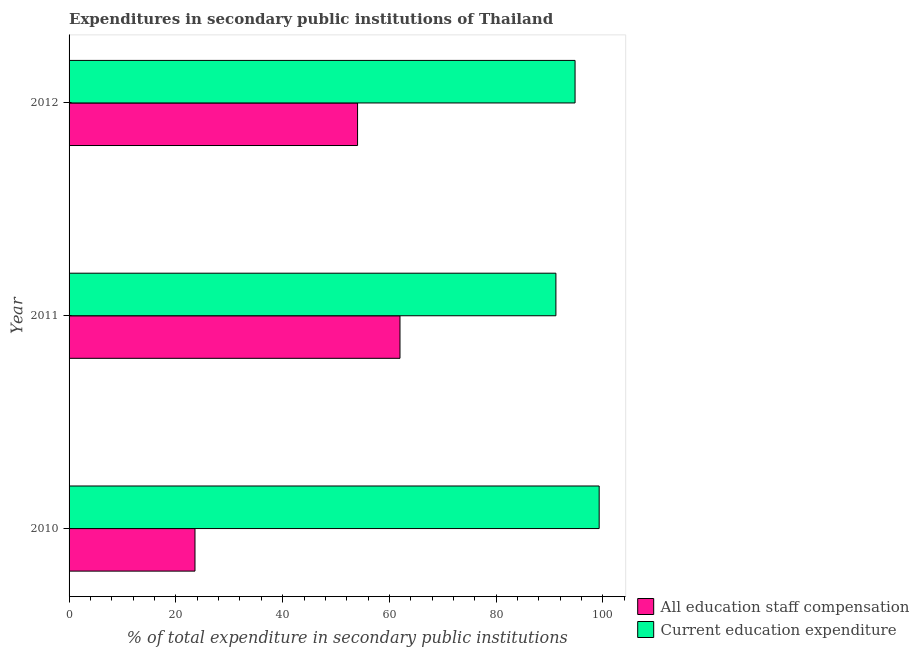How many different coloured bars are there?
Provide a short and direct response. 2. How many groups of bars are there?
Provide a short and direct response. 3. How many bars are there on the 2nd tick from the top?
Your answer should be very brief. 2. How many bars are there on the 1st tick from the bottom?
Offer a very short reply. 2. What is the label of the 2nd group of bars from the top?
Your answer should be very brief. 2011. What is the expenditure in education in 2012?
Your answer should be very brief. 94.77. Across all years, what is the maximum expenditure in education?
Make the answer very short. 99.29. Across all years, what is the minimum expenditure in education?
Your answer should be very brief. 91.18. In which year was the expenditure in staff compensation minimum?
Your answer should be compact. 2010. What is the total expenditure in staff compensation in the graph?
Your answer should be compact. 139.59. What is the difference between the expenditure in education in 2010 and that in 2011?
Give a very brief answer. 8.1. What is the difference between the expenditure in staff compensation in 2011 and the expenditure in education in 2010?
Offer a terse response. -37.31. What is the average expenditure in education per year?
Offer a terse response. 95.08. In the year 2010, what is the difference between the expenditure in education and expenditure in staff compensation?
Your answer should be very brief. 75.7. What is the ratio of the expenditure in staff compensation in 2010 to that in 2011?
Your response must be concise. 0.38. Is the expenditure in education in 2011 less than that in 2012?
Provide a succinct answer. Yes. Is the difference between the expenditure in staff compensation in 2010 and 2012 greater than the difference between the expenditure in education in 2010 and 2012?
Keep it short and to the point. No. What is the difference between the highest and the second highest expenditure in education?
Make the answer very short. 4.52. In how many years, is the expenditure in education greater than the average expenditure in education taken over all years?
Give a very brief answer. 1. What does the 1st bar from the top in 2012 represents?
Provide a succinct answer. Current education expenditure. What does the 2nd bar from the bottom in 2010 represents?
Keep it short and to the point. Current education expenditure. How many bars are there?
Your answer should be very brief. 6. Are the values on the major ticks of X-axis written in scientific E-notation?
Provide a succinct answer. No. Does the graph contain grids?
Your response must be concise. No. How are the legend labels stacked?
Your answer should be very brief. Vertical. What is the title of the graph?
Make the answer very short. Expenditures in secondary public institutions of Thailand. What is the label or title of the X-axis?
Make the answer very short. % of total expenditure in secondary public institutions. What is the % of total expenditure in secondary public institutions in All education staff compensation in 2010?
Ensure brevity in your answer.  23.58. What is the % of total expenditure in secondary public institutions of Current education expenditure in 2010?
Make the answer very short. 99.29. What is the % of total expenditure in secondary public institutions of All education staff compensation in 2011?
Offer a very short reply. 61.98. What is the % of total expenditure in secondary public institutions of Current education expenditure in 2011?
Provide a short and direct response. 91.18. What is the % of total expenditure in secondary public institutions in All education staff compensation in 2012?
Your response must be concise. 54.03. What is the % of total expenditure in secondary public institutions in Current education expenditure in 2012?
Give a very brief answer. 94.77. Across all years, what is the maximum % of total expenditure in secondary public institutions of All education staff compensation?
Give a very brief answer. 61.98. Across all years, what is the maximum % of total expenditure in secondary public institutions of Current education expenditure?
Ensure brevity in your answer.  99.29. Across all years, what is the minimum % of total expenditure in secondary public institutions in All education staff compensation?
Give a very brief answer. 23.58. Across all years, what is the minimum % of total expenditure in secondary public institutions in Current education expenditure?
Ensure brevity in your answer.  91.18. What is the total % of total expenditure in secondary public institutions in All education staff compensation in the graph?
Make the answer very short. 139.59. What is the total % of total expenditure in secondary public institutions in Current education expenditure in the graph?
Offer a terse response. 285.24. What is the difference between the % of total expenditure in secondary public institutions in All education staff compensation in 2010 and that in 2011?
Your answer should be very brief. -38.4. What is the difference between the % of total expenditure in secondary public institutions in Current education expenditure in 2010 and that in 2011?
Provide a succinct answer. 8.1. What is the difference between the % of total expenditure in secondary public institutions of All education staff compensation in 2010 and that in 2012?
Ensure brevity in your answer.  -30.45. What is the difference between the % of total expenditure in secondary public institutions in Current education expenditure in 2010 and that in 2012?
Offer a terse response. 4.52. What is the difference between the % of total expenditure in secondary public institutions in All education staff compensation in 2011 and that in 2012?
Provide a short and direct response. 7.95. What is the difference between the % of total expenditure in secondary public institutions of Current education expenditure in 2011 and that in 2012?
Offer a very short reply. -3.59. What is the difference between the % of total expenditure in secondary public institutions in All education staff compensation in 2010 and the % of total expenditure in secondary public institutions in Current education expenditure in 2011?
Your response must be concise. -67.6. What is the difference between the % of total expenditure in secondary public institutions in All education staff compensation in 2010 and the % of total expenditure in secondary public institutions in Current education expenditure in 2012?
Make the answer very short. -71.19. What is the difference between the % of total expenditure in secondary public institutions in All education staff compensation in 2011 and the % of total expenditure in secondary public institutions in Current education expenditure in 2012?
Ensure brevity in your answer.  -32.79. What is the average % of total expenditure in secondary public institutions of All education staff compensation per year?
Keep it short and to the point. 46.53. What is the average % of total expenditure in secondary public institutions in Current education expenditure per year?
Make the answer very short. 95.08. In the year 2010, what is the difference between the % of total expenditure in secondary public institutions in All education staff compensation and % of total expenditure in secondary public institutions in Current education expenditure?
Provide a short and direct response. -75.7. In the year 2011, what is the difference between the % of total expenditure in secondary public institutions in All education staff compensation and % of total expenditure in secondary public institutions in Current education expenditure?
Offer a terse response. -29.2. In the year 2012, what is the difference between the % of total expenditure in secondary public institutions in All education staff compensation and % of total expenditure in secondary public institutions in Current education expenditure?
Your response must be concise. -40.74. What is the ratio of the % of total expenditure in secondary public institutions in All education staff compensation in 2010 to that in 2011?
Offer a very short reply. 0.38. What is the ratio of the % of total expenditure in secondary public institutions in Current education expenditure in 2010 to that in 2011?
Ensure brevity in your answer.  1.09. What is the ratio of the % of total expenditure in secondary public institutions in All education staff compensation in 2010 to that in 2012?
Offer a very short reply. 0.44. What is the ratio of the % of total expenditure in secondary public institutions in Current education expenditure in 2010 to that in 2012?
Your response must be concise. 1.05. What is the ratio of the % of total expenditure in secondary public institutions of All education staff compensation in 2011 to that in 2012?
Offer a very short reply. 1.15. What is the ratio of the % of total expenditure in secondary public institutions of Current education expenditure in 2011 to that in 2012?
Ensure brevity in your answer.  0.96. What is the difference between the highest and the second highest % of total expenditure in secondary public institutions in All education staff compensation?
Provide a short and direct response. 7.95. What is the difference between the highest and the second highest % of total expenditure in secondary public institutions of Current education expenditure?
Offer a very short reply. 4.52. What is the difference between the highest and the lowest % of total expenditure in secondary public institutions in All education staff compensation?
Offer a very short reply. 38.4. What is the difference between the highest and the lowest % of total expenditure in secondary public institutions in Current education expenditure?
Provide a succinct answer. 8.1. 